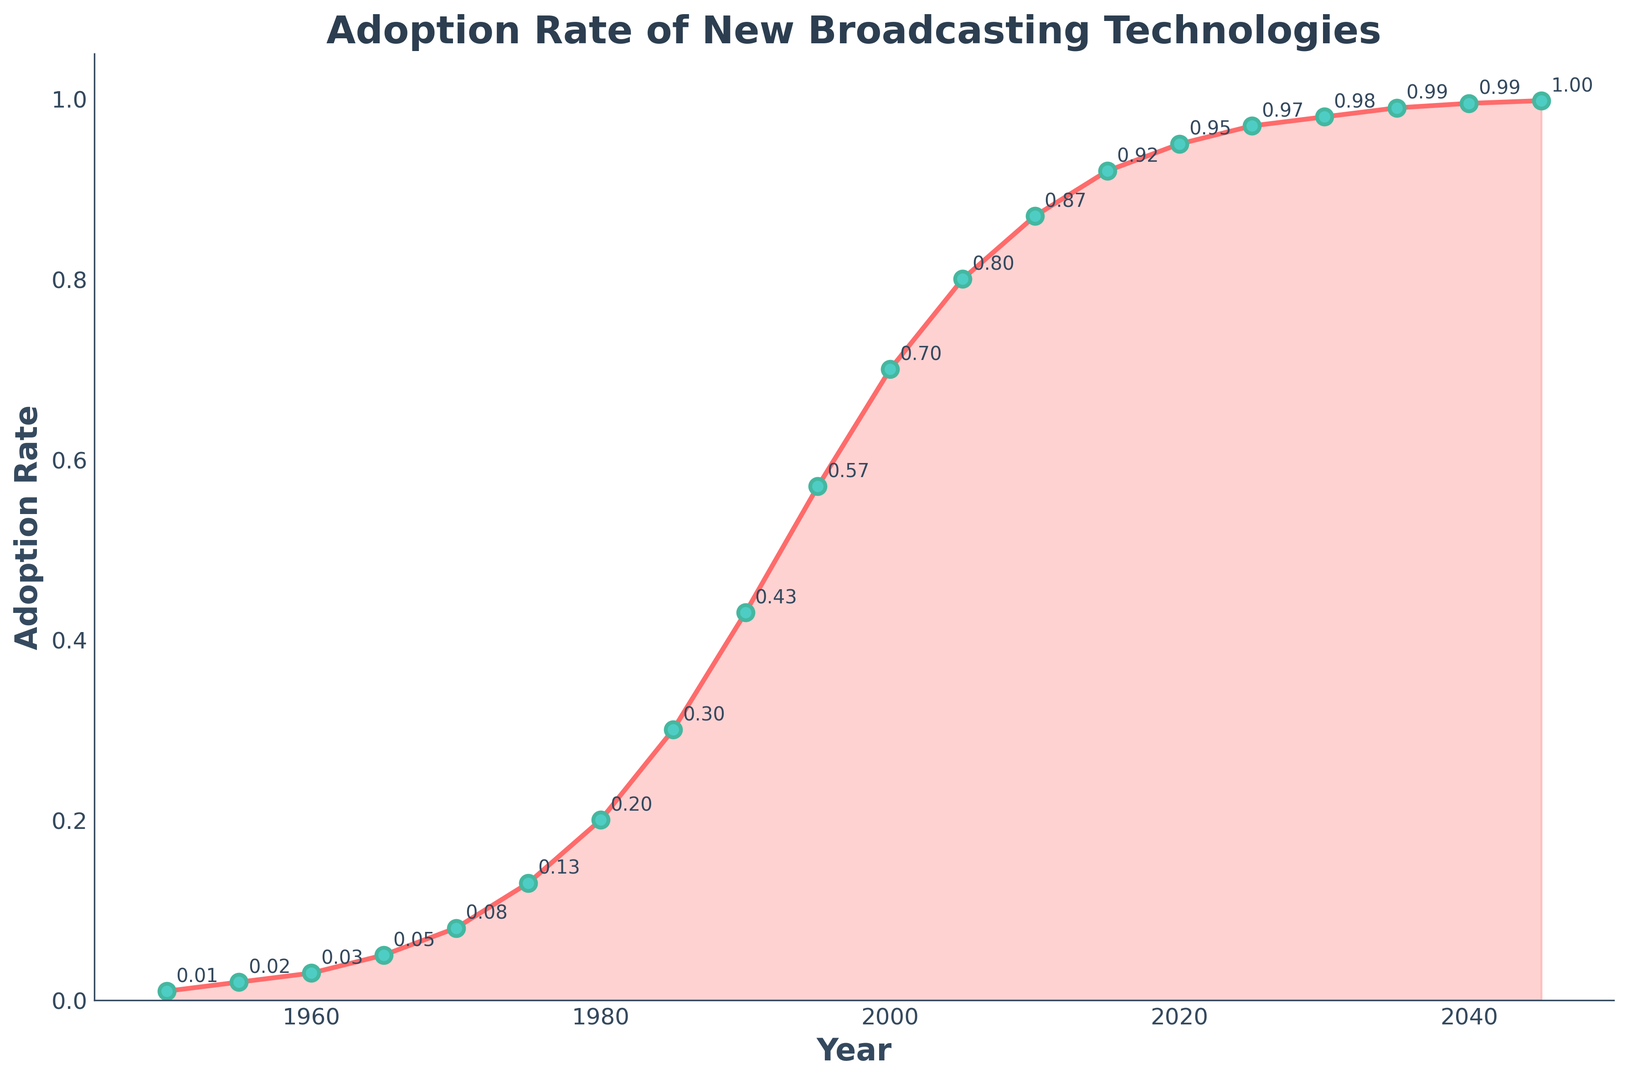What is the adoption rate in the year 2000? The figure shows the adoption rate for the year 2000 labeled directly next to the data point on the curve. Locate the year 2000 on the x-axis and find the corresponding y-value, which is labeled.
Answer: 0.70 Between which years did the adoption rate increase the most? Observe the steepness of the curve in the figure. The steepest part of the curve represents the period with the most significant increase in adoption rate. Identify the segment where the curve rises most sharply.
Answer: 1980 to 2000 What is the average adoption rate from 1990 to 2000? Identify the adoption rates for the years 1990 (0.43), 1995 (0.57), and 2000 (0.70). Calculate the average: (0.43 + 0.57 + 0.70) / 3.
Answer: 0.57 Which year marks the first noticeable uptick in adoption rate? Scan the graph for the earliest significant upwards trend. Identify the year at which the curve first displays a notable increase in slope from near-flat.
Answer: 1965 By how much did the adoption rate increase from 1985 to 1995? Identify the adoption rates for 1985 (0.30) and 1995 (0.57). Subtract the former from the latter: 0.57 - 0.30.
Answer: 0.27 What is the color of the line and the markers on it? Describe the appearance of both the line and the markers. The line is a specific color, and the markers have distinct color features.
Answer: Line: Red, Markers: Green with teal edges What is the adoption rate difference between 1990 and 2015? Identify the adoption rates for 1990 (0.43) and 2015 (0.92) from the figure. Subtract the rate in 1990 from that in 2015: 0.92 - 0.43.
Answer: 0.49 When does the adoption rate approach 1.0? Look for the year when the adoption rate curve approaches its highest value, near 1.0, towards the end of the plot.
Answer: 2035 